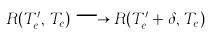<formula> <loc_0><loc_0><loc_500><loc_500>R ( T _ { e } ^ { \prime } , \, T _ { e } ) \longrightarrow R ( T _ { e } ^ { \prime } + \delta , \, T _ { e } )</formula> 